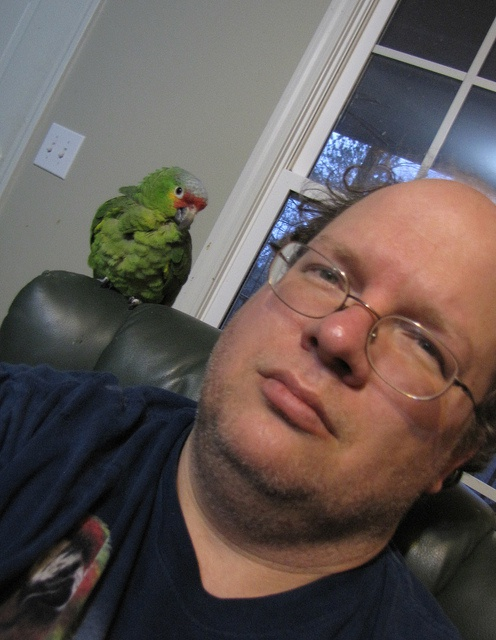Describe the objects in this image and their specific colors. I can see people in gray, black, brown, and maroon tones, chair in gray, black, and purple tones, and bird in gray, darkgreen, and black tones in this image. 